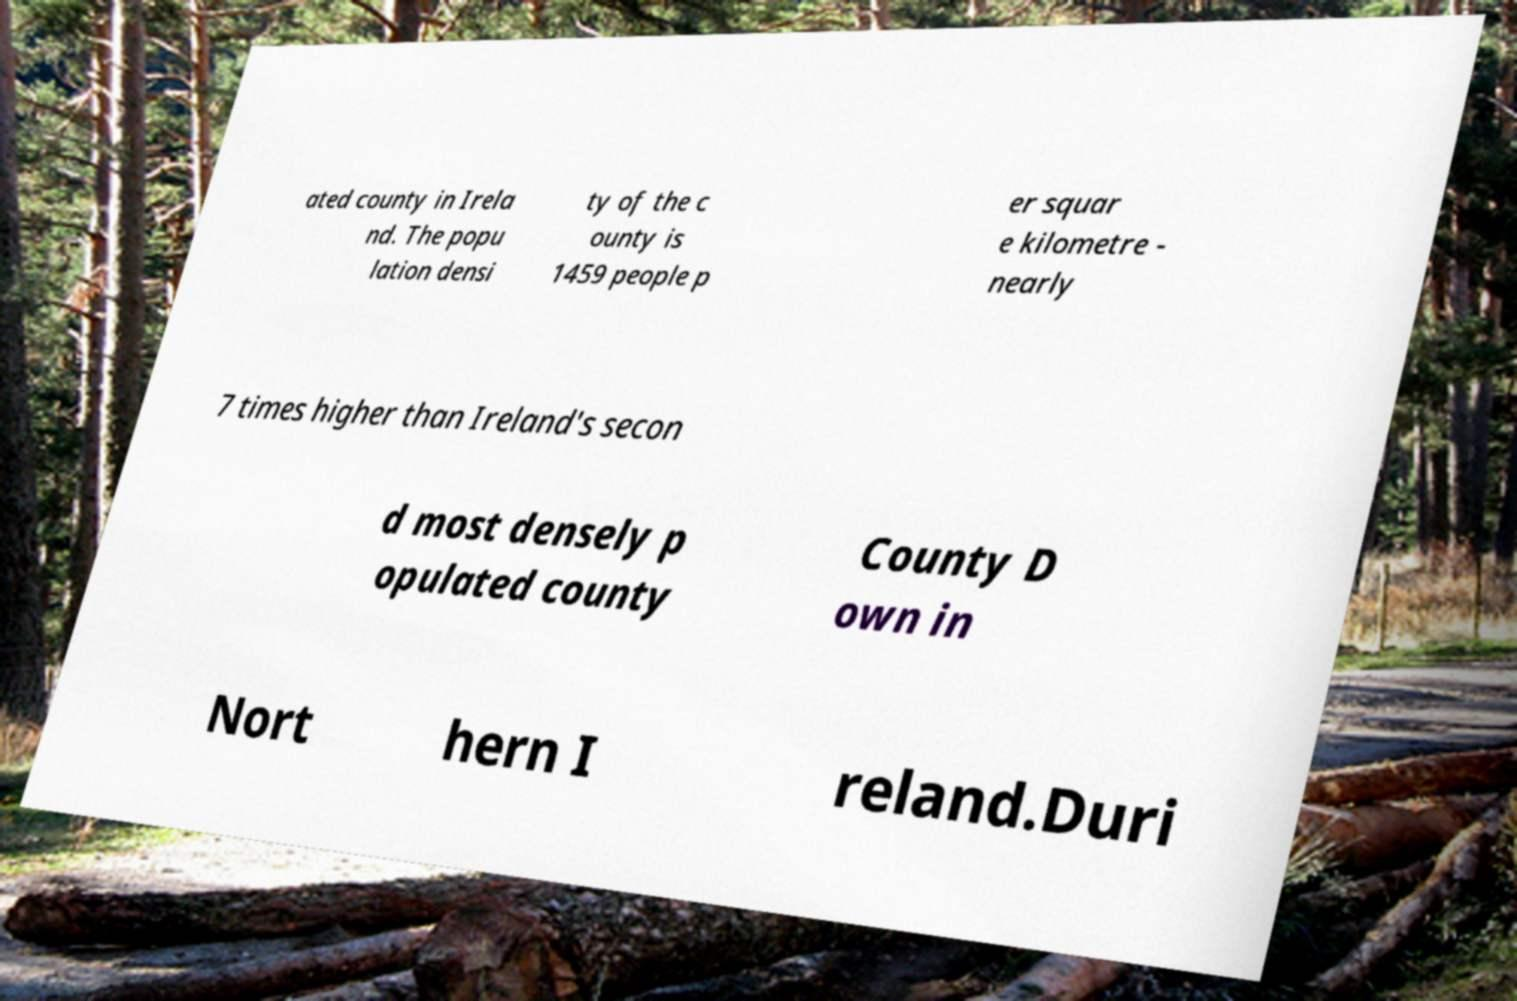I need the written content from this picture converted into text. Can you do that? ated county in Irela nd. The popu lation densi ty of the c ounty is 1459 people p er squar e kilometre - nearly 7 times higher than Ireland's secon d most densely p opulated county County D own in Nort hern I reland.Duri 